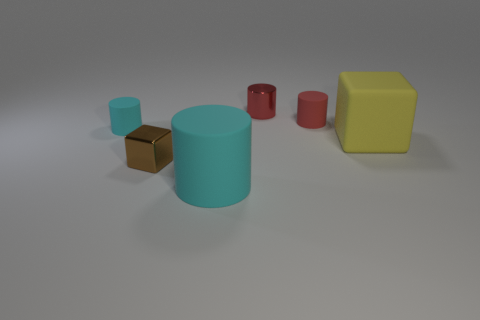There is a matte thing that is behind the object that is to the left of the tiny brown shiny cube; what color is it?
Provide a succinct answer. Red. How many objects are either cylinders in front of the small red matte object or red cylinders?
Keep it short and to the point. 4. There is a red rubber cylinder; does it have the same size as the block on the right side of the small red metal cylinder?
Your answer should be compact. No. What number of large things are either cyan metal cylinders or metal things?
Keep it short and to the point. 0. What is the shape of the small brown object?
Provide a short and direct response. Cube. Are there any blue cylinders made of the same material as the large cyan cylinder?
Give a very brief answer. No. Are there more green cubes than big cylinders?
Ensure brevity in your answer.  No. Are the large cyan object and the tiny brown block made of the same material?
Offer a terse response. No. How many matte objects are big cyan cylinders or small green cylinders?
Ensure brevity in your answer.  1. There is a metallic cylinder that is the same size as the metal block; what color is it?
Provide a succinct answer. Red. 